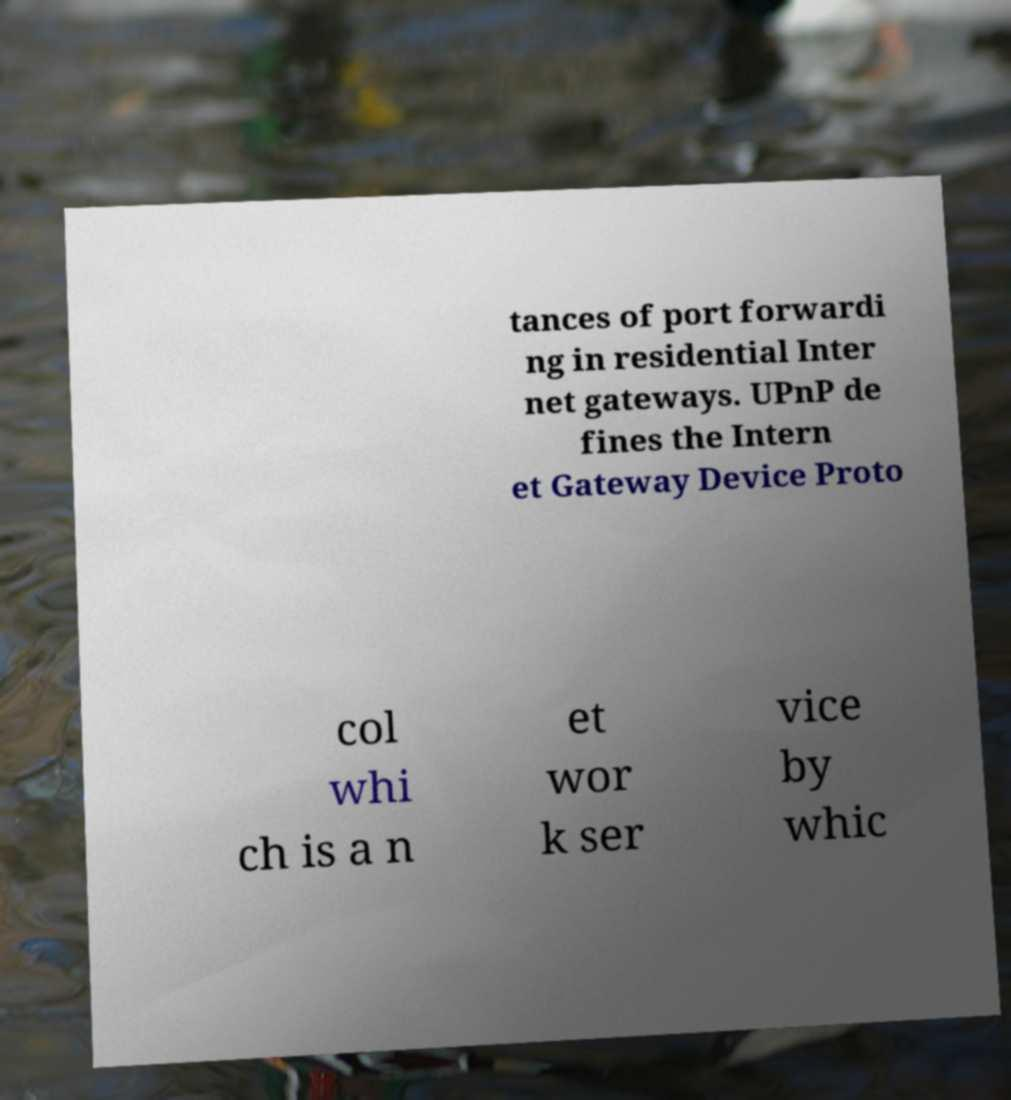Please identify and transcribe the text found in this image. tances of port forwardi ng in residential Inter net gateways. UPnP de fines the Intern et Gateway Device Proto col whi ch is a n et wor k ser vice by whic 